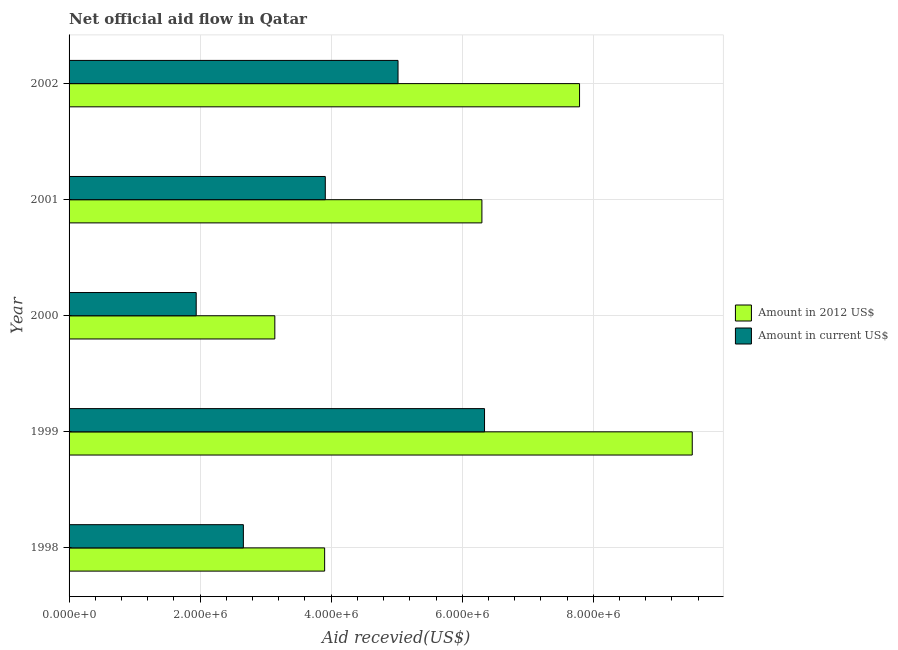How many different coloured bars are there?
Offer a terse response. 2. How many groups of bars are there?
Your answer should be very brief. 5. How many bars are there on the 4th tick from the bottom?
Provide a short and direct response. 2. In how many cases, is the number of bars for a given year not equal to the number of legend labels?
Ensure brevity in your answer.  0. What is the amount of aid received(expressed in 2012 us$) in 2001?
Your answer should be compact. 6.30e+06. Across all years, what is the maximum amount of aid received(expressed in us$)?
Offer a terse response. 6.34e+06. Across all years, what is the minimum amount of aid received(expressed in 2012 us$)?
Give a very brief answer. 3.14e+06. In which year was the amount of aid received(expressed in 2012 us$) maximum?
Offer a very short reply. 1999. What is the total amount of aid received(expressed in us$) in the graph?
Your answer should be very brief. 1.99e+07. What is the difference between the amount of aid received(expressed in 2012 us$) in 1998 and that in 2000?
Offer a terse response. 7.60e+05. What is the difference between the amount of aid received(expressed in 2012 us$) in 1999 and the amount of aid received(expressed in us$) in 2002?
Offer a very short reply. 4.49e+06. What is the average amount of aid received(expressed in us$) per year?
Ensure brevity in your answer.  3.97e+06. In the year 2002, what is the difference between the amount of aid received(expressed in us$) and amount of aid received(expressed in 2012 us$)?
Your response must be concise. -2.77e+06. What is the ratio of the amount of aid received(expressed in us$) in 2000 to that in 2001?
Provide a short and direct response. 0.5. Is the amount of aid received(expressed in 2012 us$) in 2000 less than that in 2002?
Provide a short and direct response. Yes. What is the difference between the highest and the second highest amount of aid received(expressed in 2012 us$)?
Your answer should be very brief. 1.72e+06. What is the difference between the highest and the lowest amount of aid received(expressed in 2012 us$)?
Your answer should be compact. 6.37e+06. What does the 1st bar from the top in 2000 represents?
Provide a succinct answer. Amount in current US$. What does the 2nd bar from the bottom in 2002 represents?
Make the answer very short. Amount in current US$. How many bars are there?
Keep it short and to the point. 10. How many years are there in the graph?
Give a very brief answer. 5. What is the difference between two consecutive major ticks on the X-axis?
Your response must be concise. 2.00e+06. What is the title of the graph?
Offer a very short reply. Net official aid flow in Qatar. Does "Constant 2005 US$" appear as one of the legend labels in the graph?
Offer a very short reply. No. What is the label or title of the X-axis?
Make the answer very short. Aid recevied(US$). What is the label or title of the Y-axis?
Provide a short and direct response. Year. What is the Aid recevied(US$) of Amount in 2012 US$ in 1998?
Provide a succinct answer. 3.90e+06. What is the Aid recevied(US$) in Amount in current US$ in 1998?
Offer a very short reply. 2.66e+06. What is the Aid recevied(US$) of Amount in 2012 US$ in 1999?
Ensure brevity in your answer.  9.51e+06. What is the Aid recevied(US$) in Amount in current US$ in 1999?
Provide a short and direct response. 6.34e+06. What is the Aid recevied(US$) in Amount in 2012 US$ in 2000?
Keep it short and to the point. 3.14e+06. What is the Aid recevied(US$) of Amount in current US$ in 2000?
Offer a very short reply. 1.94e+06. What is the Aid recevied(US$) in Amount in 2012 US$ in 2001?
Keep it short and to the point. 6.30e+06. What is the Aid recevied(US$) of Amount in current US$ in 2001?
Provide a succinct answer. 3.91e+06. What is the Aid recevied(US$) in Amount in 2012 US$ in 2002?
Your answer should be compact. 7.79e+06. What is the Aid recevied(US$) of Amount in current US$ in 2002?
Offer a very short reply. 5.02e+06. Across all years, what is the maximum Aid recevied(US$) in Amount in 2012 US$?
Your response must be concise. 9.51e+06. Across all years, what is the maximum Aid recevied(US$) in Amount in current US$?
Ensure brevity in your answer.  6.34e+06. Across all years, what is the minimum Aid recevied(US$) of Amount in 2012 US$?
Your answer should be very brief. 3.14e+06. Across all years, what is the minimum Aid recevied(US$) of Amount in current US$?
Give a very brief answer. 1.94e+06. What is the total Aid recevied(US$) in Amount in 2012 US$ in the graph?
Make the answer very short. 3.06e+07. What is the total Aid recevied(US$) of Amount in current US$ in the graph?
Offer a terse response. 1.99e+07. What is the difference between the Aid recevied(US$) of Amount in 2012 US$ in 1998 and that in 1999?
Provide a succinct answer. -5.61e+06. What is the difference between the Aid recevied(US$) in Amount in current US$ in 1998 and that in 1999?
Your response must be concise. -3.68e+06. What is the difference between the Aid recevied(US$) in Amount in 2012 US$ in 1998 and that in 2000?
Your answer should be compact. 7.60e+05. What is the difference between the Aid recevied(US$) of Amount in current US$ in 1998 and that in 2000?
Make the answer very short. 7.20e+05. What is the difference between the Aid recevied(US$) in Amount in 2012 US$ in 1998 and that in 2001?
Offer a very short reply. -2.40e+06. What is the difference between the Aid recevied(US$) of Amount in current US$ in 1998 and that in 2001?
Make the answer very short. -1.25e+06. What is the difference between the Aid recevied(US$) of Amount in 2012 US$ in 1998 and that in 2002?
Give a very brief answer. -3.89e+06. What is the difference between the Aid recevied(US$) in Amount in current US$ in 1998 and that in 2002?
Keep it short and to the point. -2.36e+06. What is the difference between the Aid recevied(US$) in Amount in 2012 US$ in 1999 and that in 2000?
Your response must be concise. 6.37e+06. What is the difference between the Aid recevied(US$) in Amount in current US$ in 1999 and that in 2000?
Ensure brevity in your answer.  4.40e+06. What is the difference between the Aid recevied(US$) in Amount in 2012 US$ in 1999 and that in 2001?
Keep it short and to the point. 3.21e+06. What is the difference between the Aid recevied(US$) of Amount in current US$ in 1999 and that in 2001?
Provide a succinct answer. 2.43e+06. What is the difference between the Aid recevied(US$) in Amount in 2012 US$ in 1999 and that in 2002?
Keep it short and to the point. 1.72e+06. What is the difference between the Aid recevied(US$) of Amount in current US$ in 1999 and that in 2002?
Your response must be concise. 1.32e+06. What is the difference between the Aid recevied(US$) of Amount in 2012 US$ in 2000 and that in 2001?
Provide a short and direct response. -3.16e+06. What is the difference between the Aid recevied(US$) in Amount in current US$ in 2000 and that in 2001?
Your answer should be very brief. -1.97e+06. What is the difference between the Aid recevied(US$) of Amount in 2012 US$ in 2000 and that in 2002?
Keep it short and to the point. -4.65e+06. What is the difference between the Aid recevied(US$) in Amount in current US$ in 2000 and that in 2002?
Provide a short and direct response. -3.08e+06. What is the difference between the Aid recevied(US$) in Amount in 2012 US$ in 2001 and that in 2002?
Ensure brevity in your answer.  -1.49e+06. What is the difference between the Aid recevied(US$) in Amount in current US$ in 2001 and that in 2002?
Your answer should be compact. -1.11e+06. What is the difference between the Aid recevied(US$) of Amount in 2012 US$ in 1998 and the Aid recevied(US$) of Amount in current US$ in 1999?
Give a very brief answer. -2.44e+06. What is the difference between the Aid recevied(US$) in Amount in 2012 US$ in 1998 and the Aid recevied(US$) in Amount in current US$ in 2000?
Your answer should be compact. 1.96e+06. What is the difference between the Aid recevied(US$) in Amount in 2012 US$ in 1998 and the Aid recevied(US$) in Amount in current US$ in 2002?
Your response must be concise. -1.12e+06. What is the difference between the Aid recevied(US$) in Amount in 2012 US$ in 1999 and the Aid recevied(US$) in Amount in current US$ in 2000?
Ensure brevity in your answer.  7.57e+06. What is the difference between the Aid recevied(US$) in Amount in 2012 US$ in 1999 and the Aid recevied(US$) in Amount in current US$ in 2001?
Provide a succinct answer. 5.60e+06. What is the difference between the Aid recevied(US$) in Amount in 2012 US$ in 1999 and the Aid recevied(US$) in Amount in current US$ in 2002?
Your answer should be very brief. 4.49e+06. What is the difference between the Aid recevied(US$) in Amount in 2012 US$ in 2000 and the Aid recevied(US$) in Amount in current US$ in 2001?
Offer a very short reply. -7.70e+05. What is the difference between the Aid recevied(US$) in Amount in 2012 US$ in 2000 and the Aid recevied(US$) in Amount in current US$ in 2002?
Provide a short and direct response. -1.88e+06. What is the difference between the Aid recevied(US$) of Amount in 2012 US$ in 2001 and the Aid recevied(US$) of Amount in current US$ in 2002?
Offer a terse response. 1.28e+06. What is the average Aid recevied(US$) of Amount in 2012 US$ per year?
Your answer should be compact. 6.13e+06. What is the average Aid recevied(US$) of Amount in current US$ per year?
Your answer should be very brief. 3.97e+06. In the year 1998, what is the difference between the Aid recevied(US$) of Amount in 2012 US$ and Aid recevied(US$) of Amount in current US$?
Give a very brief answer. 1.24e+06. In the year 1999, what is the difference between the Aid recevied(US$) of Amount in 2012 US$ and Aid recevied(US$) of Amount in current US$?
Keep it short and to the point. 3.17e+06. In the year 2000, what is the difference between the Aid recevied(US$) in Amount in 2012 US$ and Aid recevied(US$) in Amount in current US$?
Give a very brief answer. 1.20e+06. In the year 2001, what is the difference between the Aid recevied(US$) in Amount in 2012 US$ and Aid recevied(US$) in Amount in current US$?
Provide a short and direct response. 2.39e+06. In the year 2002, what is the difference between the Aid recevied(US$) of Amount in 2012 US$ and Aid recevied(US$) of Amount in current US$?
Offer a very short reply. 2.77e+06. What is the ratio of the Aid recevied(US$) in Amount in 2012 US$ in 1998 to that in 1999?
Keep it short and to the point. 0.41. What is the ratio of the Aid recevied(US$) of Amount in current US$ in 1998 to that in 1999?
Keep it short and to the point. 0.42. What is the ratio of the Aid recevied(US$) in Amount in 2012 US$ in 1998 to that in 2000?
Your answer should be compact. 1.24. What is the ratio of the Aid recevied(US$) in Amount in current US$ in 1998 to that in 2000?
Keep it short and to the point. 1.37. What is the ratio of the Aid recevied(US$) of Amount in 2012 US$ in 1998 to that in 2001?
Provide a succinct answer. 0.62. What is the ratio of the Aid recevied(US$) of Amount in current US$ in 1998 to that in 2001?
Offer a terse response. 0.68. What is the ratio of the Aid recevied(US$) of Amount in 2012 US$ in 1998 to that in 2002?
Your answer should be very brief. 0.5. What is the ratio of the Aid recevied(US$) in Amount in current US$ in 1998 to that in 2002?
Give a very brief answer. 0.53. What is the ratio of the Aid recevied(US$) in Amount in 2012 US$ in 1999 to that in 2000?
Offer a terse response. 3.03. What is the ratio of the Aid recevied(US$) in Amount in current US$ in 1999 to that in 2000?
Your answer should be very brief. 3.27. What is the ratio of the Aid recevied(US$) of Amount in 2012 US$ in 1999 to that in 2001?
Your answer should be very brief. 1.51. What is the ratio of the Aid recevied(US$) in Amount in current US$ in 1999 to that in 2001?
Provide a short and direct response. 1.62. What is the ratio of the Aid recevied(US$) in Amount in 2012 US$ in 1999 to that in 2002?
Your answer should be very brief. 1.22. What is the ratio of the Aid recevied(US$) in Amount in current US$ in 1999 to that in 2002?
Your answer should be compact. 1.26. What is the ratio of the Aid recevied(US$) in Amount in 2012 US$ in 2000 to that in 2001?
Ensure brevity in your answer.  0.5. What is the ratio of the Aid recevied(US$) in Amount in current US$ in 2000 to that in 2001?
Provide a short and direct response. 0.5. What is the ratio of the Aid recevied(US$) in Amount in 2012 US$ in 2000 to that in 2002?
Give a very brief answer. 0.4. What is the ratio of the Aid recevied(US$) of Amount in current US$ in 2000 to that in 2002?
Ensure brevity in your answer.  0.39. What is the ratio of the Aid recevied(US$) in Amount in 2012 US$ in 2001 to that in 2002?
Make the answer very short. 0.81. What is the ratio of the Aid recevied(US$) of Amount in current US$ in 2001 to that in 2002?
Provide a succinct answer. 0.78. What is the difference between the highest and the second highest Aid recevied(US$) of Amount in 2012 US$?
Provide a short and direct response. 1.72e+06. What is the difference between the highest and the second highest Aid recevied(US$) of Amount in current US$?
Offer a very short reply. 1.32e+06. What is the difference between the highest and the lowest Aid recevied(US$) in Amount in 2012 US$?
Offer a very short reply. 6.37e+06. What is the difference between the highest and the lowest Aid recevied(US$) in Amount in current US$?
Offer a terse response. 4.40e+06. 